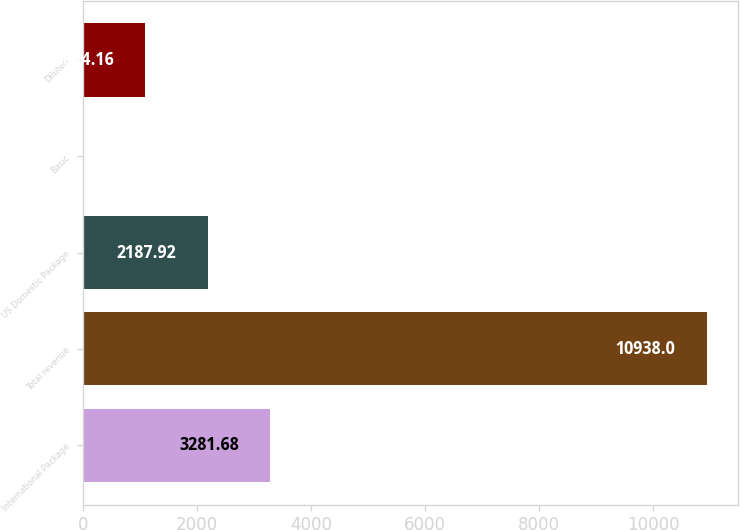<chart> <loc_0><loc_0><loc_500><loc_500><bar_chart><fcel>International Package<fcel>Total revenue<fcel>US Domestic Package<fcel>Basic<fcel>Diluted<nl><fcel>3281.68<fcel>10938<fcel>2187.92<fcel>0.4<fcel>1094.16<nl></chart> 